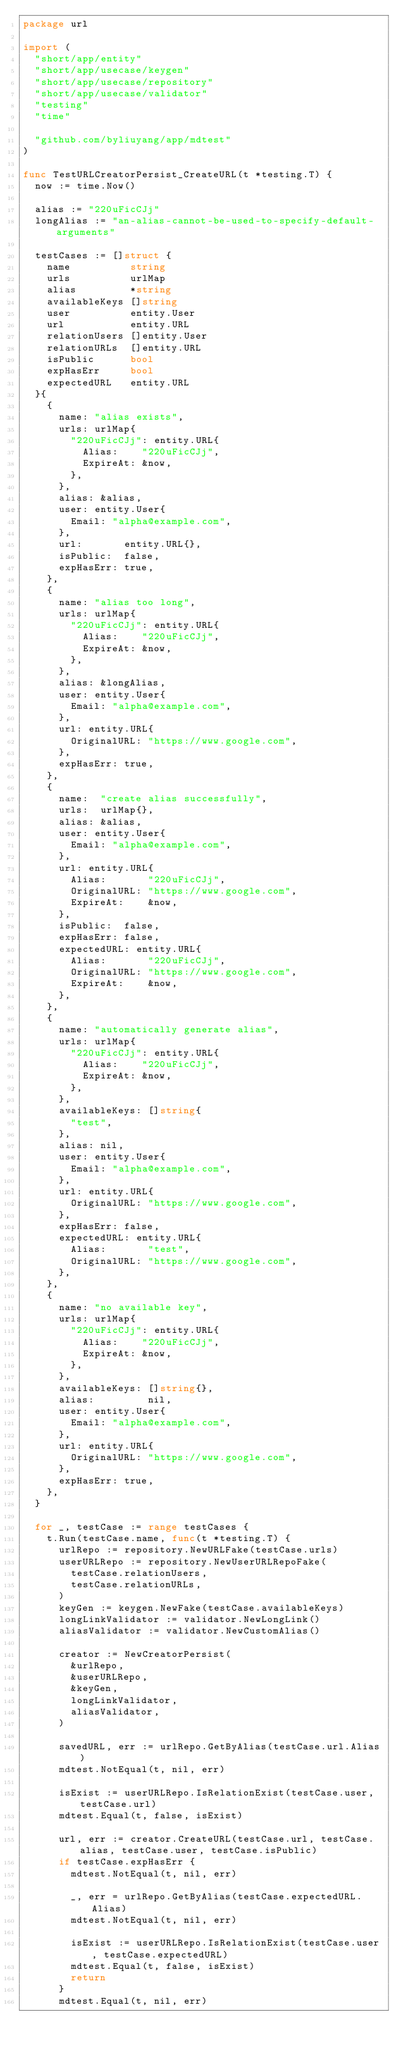<code> <loc_0><loc_0><loc_500><loc_500><_Go_>package url

import (
	"short/app/entity"
	"short/app/usecase/keygen"
	"short/app/usecase/repository"
	"short/app/usecase/validator"
	"testing"
	"time"

	"github.com/byliuyang/app/mdtest"
)

func TestURLCreatorPersist_CreateURL(t *testing.T) {
	now := time.Now()

	alias := "220uFicCJj"
	longAlias := "an-alias-cannot-be-used-to-specify-default-arguments"

	testCases := []struct {
		name          string
		urls          urlMap
		alias         *string
		availableKeys []string
		user          entity.User
		url           entity.URL
		relationUsers []entity.User
		relationURLs  []entity.URL
		isPublic      bool
		expHasErr     bool
		expectedURL   entity.URL
	}{
		{
			name: "alias exists",
			urls: urlMap{
				"220uFicCJj": entity.URL{
					Alias:    "220uFicCJj",
					ExpireAt: &now,
				},
			},
			alias: &alias,
			user: entity.User{
				Email: "alpha@example.com",
			},
			url:       entity.URL{},
			isPublic:  false,
			expHasErr: true,
		},
		{
			name: "alias too long",
			urls: urlMap{
				"220uFicCJj": entity.URL{
					Alias:    "220uFicCJj",
					ExpireAt: &now,
				},
			},
			alias: &longAlias,
			user: entity.User{
				Email: "alpha@example.com",
			},
			url: entity.URL{
				OriginalURL: "https://www.google.com",
			},
			expHasErr: true,
		},
		{
			name:  "create alias successfully",
			urls:  urlMap{},
			alias: &alias,
			user: entity.User{
				Email: "alpha@example.com",
			},
			url: entity.URL{
				Alias:       "220uFicCJj",
				OriginalURL: "https://www.google.com",
				ExpireAt:    &now,
			},
			isPublic:  false,
			expHasErr: false,
			expectedURL: entity.URL{
				Alias:       "220uFicCJj",
				OriginalURL: "https://www.google.com",
				ExpireAt:    &now,
			},
		},
		{
			name: "automatically generate alias",
			urls: urlMap{
				"220uFicCJj": entity.URL{
					Alias:    "220uFicCJj",
					ExpireAt: &now,
				},
			},
			availableKeys: []string{
				"test",
			},
			alias: nil,
			user: entity.User{
				Email: "alpha@example.com",
			},
			url: entity.URL{
				OriginalURL: "https://www.google.com",
			},
			expHasErr: false,
			expectedURL: entity.URL{
				Alias:       "test",
				OriginalURL: "https://www.google.com",
			},
		},
		{
			name: "no available key",
			urls: urlMap{
				"220uFicCJj": entity.URL{
					Alias:    "220uFicCJj",
					ExpireAt: &now,
				},
			},
			availableKeys: []string{},
			alias:         nil,
			user: entity.User{
				Email: "alpha@example.com",
			},
			url: entity.URL{
				OriginalURL: "https://www.google.com",
			},
			expHasErr: true,
		},
	}

	for _, testCase := range testCases {
		t.Run(testCase.name, func(t *testing.T) {
			urlRepo := repository.NewURLFake(testCase.urls)
			userURLRepo := repository.NewUserURLRepoFake(
				testCase.relationUsers,
				testCase.relationURLs,
			)
			keyGen := keygen.NewFake(testCase.availableKeys)
			longLinkValidator := validator.NewLongLink()
			aliasValidator := validator.NewCustomAlias()

			creator := NewCreatorPersist(
				&urlRepo,
				&userURLRepo,
				&keyGen,
				longLinkValidator,
				aliasValidator,
			)

			savedURL, err := urlRepo.GetByAlias(testCase.url.Alias)
			mdtest.NotEqual(t, nil, err)

			isExist := userURLRepo.IsRelationExist(testCase.user, testCase.url)
			mdtest.Equal(t, false, isExist)

			url, err := creator.CreateURL(testCase.url, testCase.alias, testCase.user, testCase.isPublic)
			if testCase.expHasErr {
				mdtest.NotEqual(t, nil, err)

				_, err = urlRepo.GetByAlias(testCase.expectedURL.Alias)
				mdtest.NotEqual(t, nil, err)

				isExist := userURLRepo.IsRelationExist(testCase.user, testCase.expectedURL)
				mdtest.Equal(t, false, isExist)
				return
			}
			mdtest.Equal(t, nil, err)</code> 